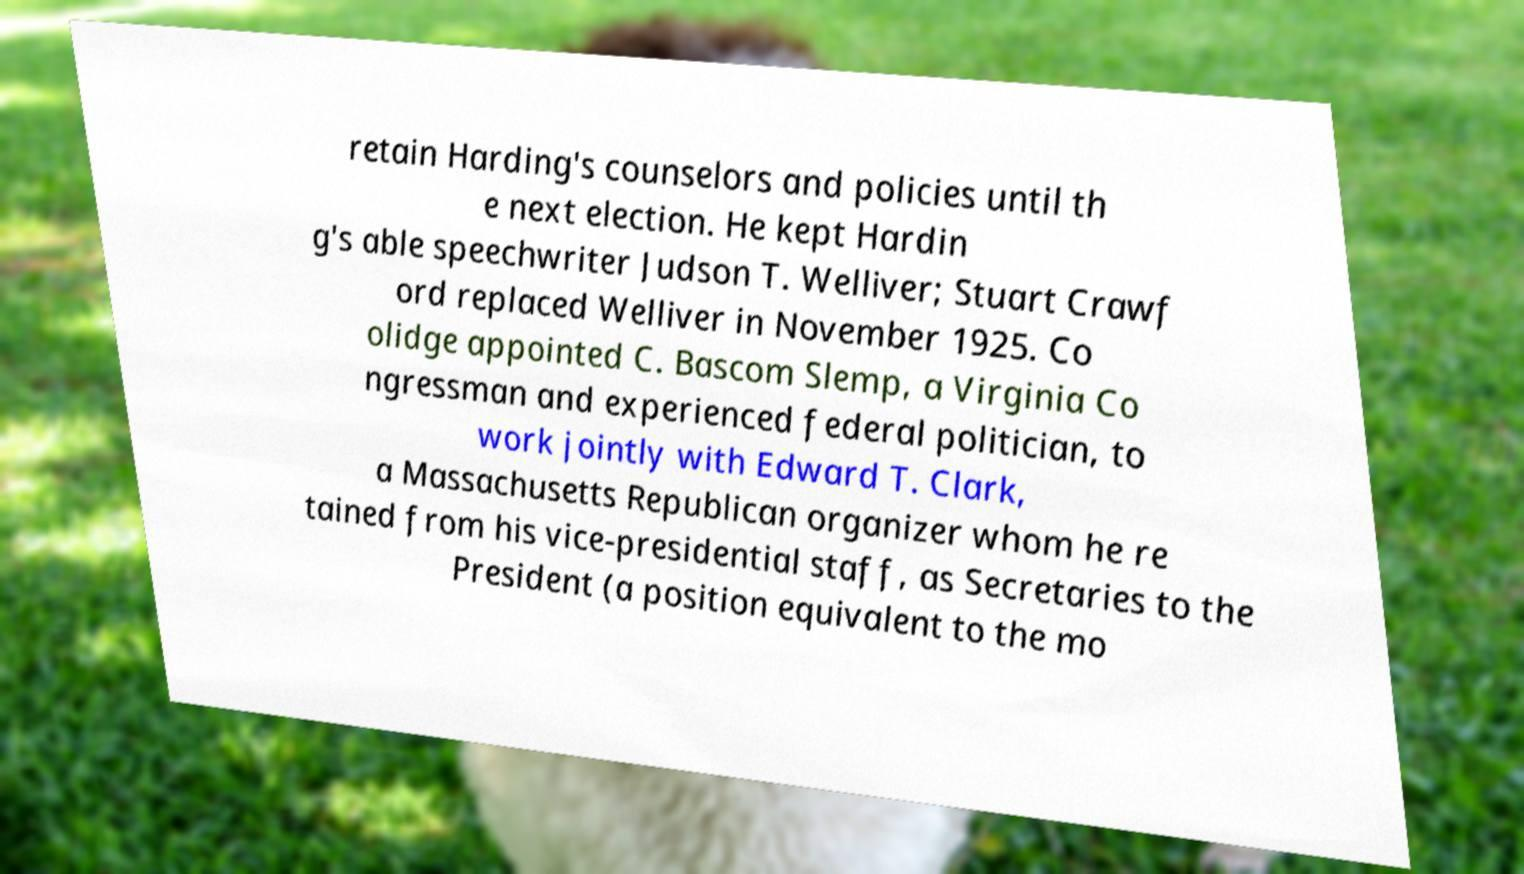I need the written content from this picture converted into text. Can you do that? retain Harding's counselors and policies until th e next election. He kept Hardin g's able speechwriter Judson T. Welliver; Stuart Crawf ord replaced Welliver in November 1925. Co olidge appointed C. Bascom Slemp, a Virginia Co ngressman and experienced federal politician, to work jointly with Edward T. Clark, a Massachusetts Republican organizer whom he re tained from his vice-presidential staff, as Secretaries to the President (a position equivalent to the mo 